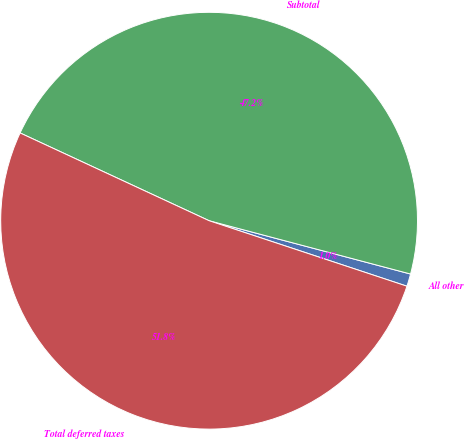<chart> <loc_0><loc_0><loc_500><loc_500><pie_chart><fcel>All other<fcel>Subtotal<fcel>Total deferred taxes<nl><fcel>0.97%<fcel>47.2%<fcel>51.83%<nl></chart> 